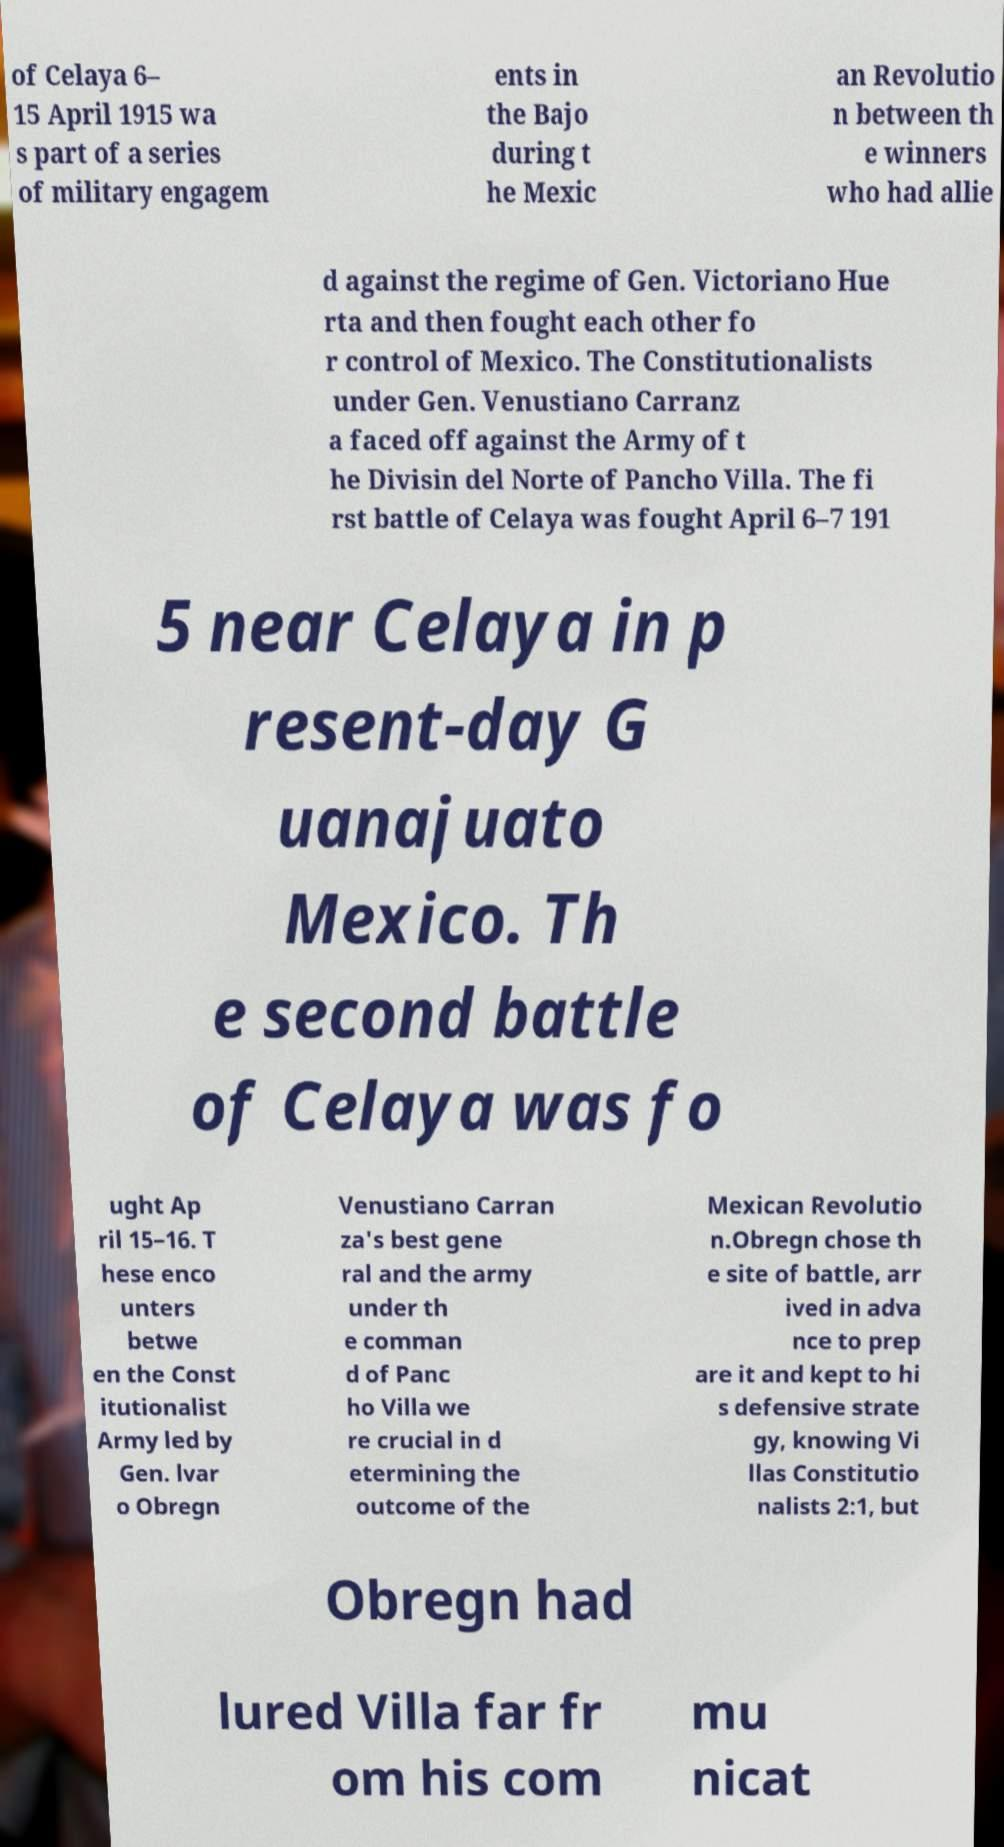Please identify and transcribe the text found in this image. of Celaya 6– 15 April 1915 wa s part of a series of military engagem ents in the Bajo during t he Mexic an Revolutio n between th e winners who had allie d against the regime of Gen. Victoriano Hue rta and then fought each other fo r control of Mexico. The Constitutionalists under Gen. Venustiano Carranz a faced off against the Army of t he Divisin del Norte of Pancho Villa. The fi rst battle of Celaya was fought April 6–7 191 5 near Celaya in p resent-day G uanajuato Mexico. Th e second battle of Celaya was fo ught Ap ril 15–16. T hese enco unters betwe en the Const itutionalist Army led by Gen. lvar o Obregn Venustiano Carran za's best gene ral and the army under th e comman d of Panc ho Villa we re crucial in d etermining the outcome of the Mexican Revolutio n.Obregn chose th e site of battle, arr ived in adva nce to prep are it and kept to hi s defensive strate gy, knowing Vi llas Constitutio nalists 2:1, but Obregn had lured Villa far fr om his com mu nicat 